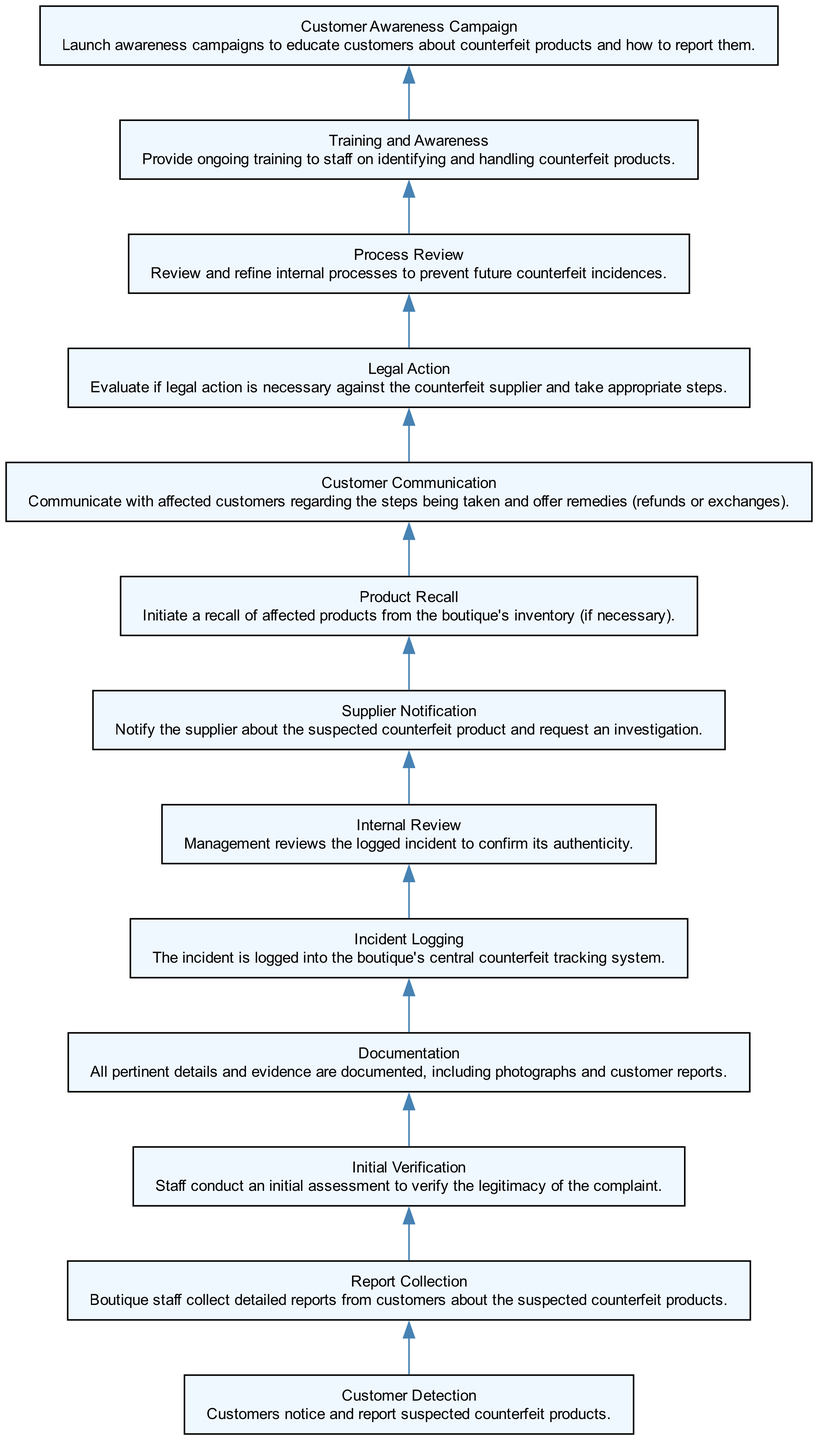What is the first step in the process? The first step in the process listed in the diagram is "Customer Detection," which indicates that customers notice and report suspected counterfeit products. This is the starting point of the flow chart.
Answer: Customer Detection How many steps are there in total? By counting the distinct steps in the flow chart, there are a total of 13 elements or steps from "Customer Detection" to "Customer Awareness Campaign." Each step represents a unique stage in addressing counterfeit incidents.
Answer: 13 What does "Incident Logging" entail? "Incident Logging" involves logging the incident into the boutique's central counterfeit tracking system, ensuring that the case is officially recorded for further action and review.
Answer: Logging into the system Which step follows "Initial Verification"? After the "Initial Verification" step, the next step in the flow chart is "Documentation." This indicates that once the initial verification is done, relevant details and evidence must be documented.
Answer: Documentation What action is taken after "Supplier Notification"? Following "Supplier Notification," the next step in the flow is "Product Recall," which signifies that if necessary, products identified as counterfeit will be recalled from the boutique's inventory.
Answer: Product Recall If the incident is confirmed in the "Internal Review," what action should follow? Once the incident is confirmed during the "Internal Review," the next step is to "Notify the Supplier" about the suspected counterfeit product, thus triggering further investigation by the supplier.
Answer: Notify the Supplier How does "Customer Communication" relate to the earlier steps? "Customer Communication" relates to the earlier steps by ensuring that once counterfeit incidents are recorded and managed, affected customers are informed about the steps being taken, addressing their concerns and offering possible remedies.
Answer: Offers remedies to customers What is the final step in the process? The final step in the process is "Customer Awareness Campaign," which indicates that after handling counterfeit incidents, the boutique takes proactive measures to educate customers about counterfeit products and how to report them.
Answer: Customer Awareness Campaign 